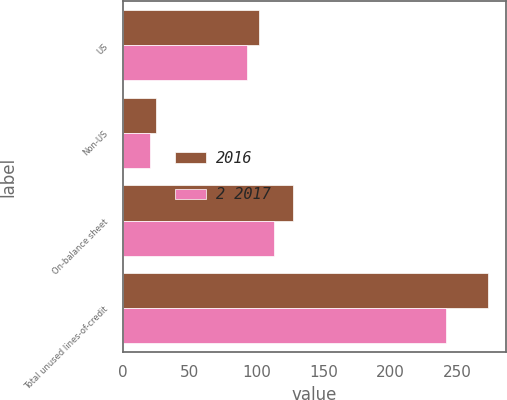Convert chart to OTSL. <chart><loc_0><loc_0><loc_500><loc_500><stacked_bar_chart><ecel><fcel>US<fcel>Non-US<fcel>On-balance sheet<fcel>Total unused lines-of-credit<nl><fcel>2016<fcel>102<fcel>25<fcel>127<fcel>273<nl><fcel>2 2017<fcel>93<fcel>20<fcel>113<fcel>242<nl></chart> 